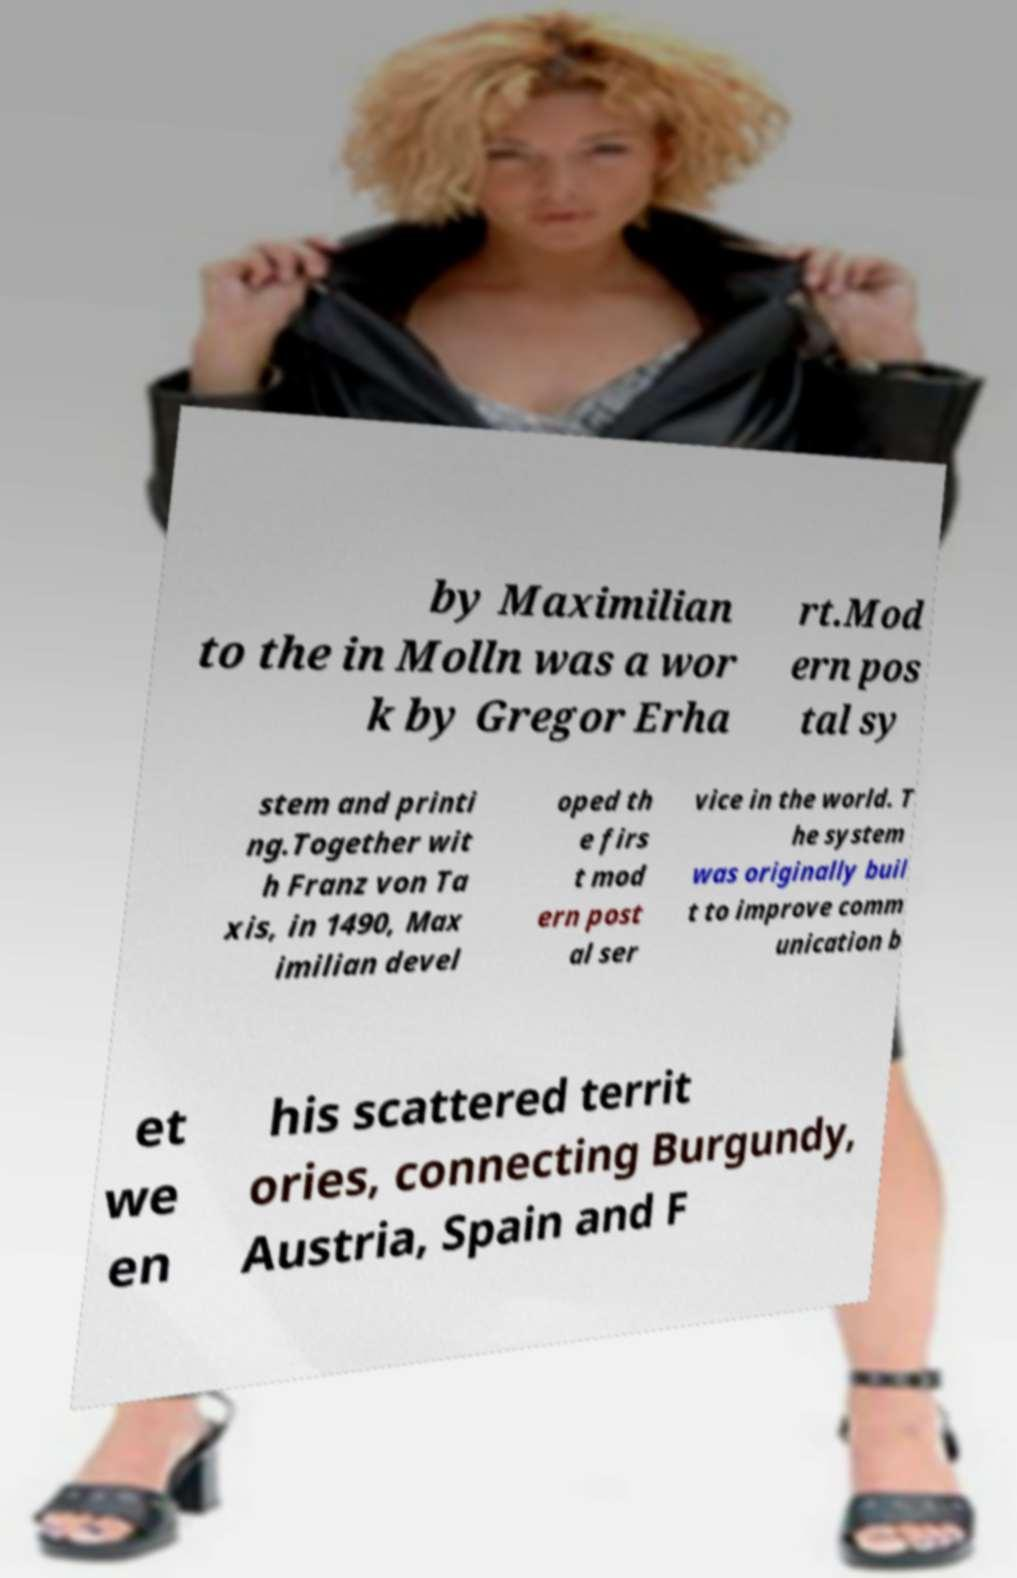I need the written content from this picture converted into text. Can you do that? by Maximilian to the in Molln was a wor k by Gregor Erha rt.Mod ern pos tal sy stem and printi ng.Together wit h Franz von Ta xis, in 1490, Max imilian devel oped th e firs t mod ern post al ser vice in the world. T he system was originally buil t to improve comm unication b et we en his scattered territ ories, connecting Burgundy, Austria, Spain and F 